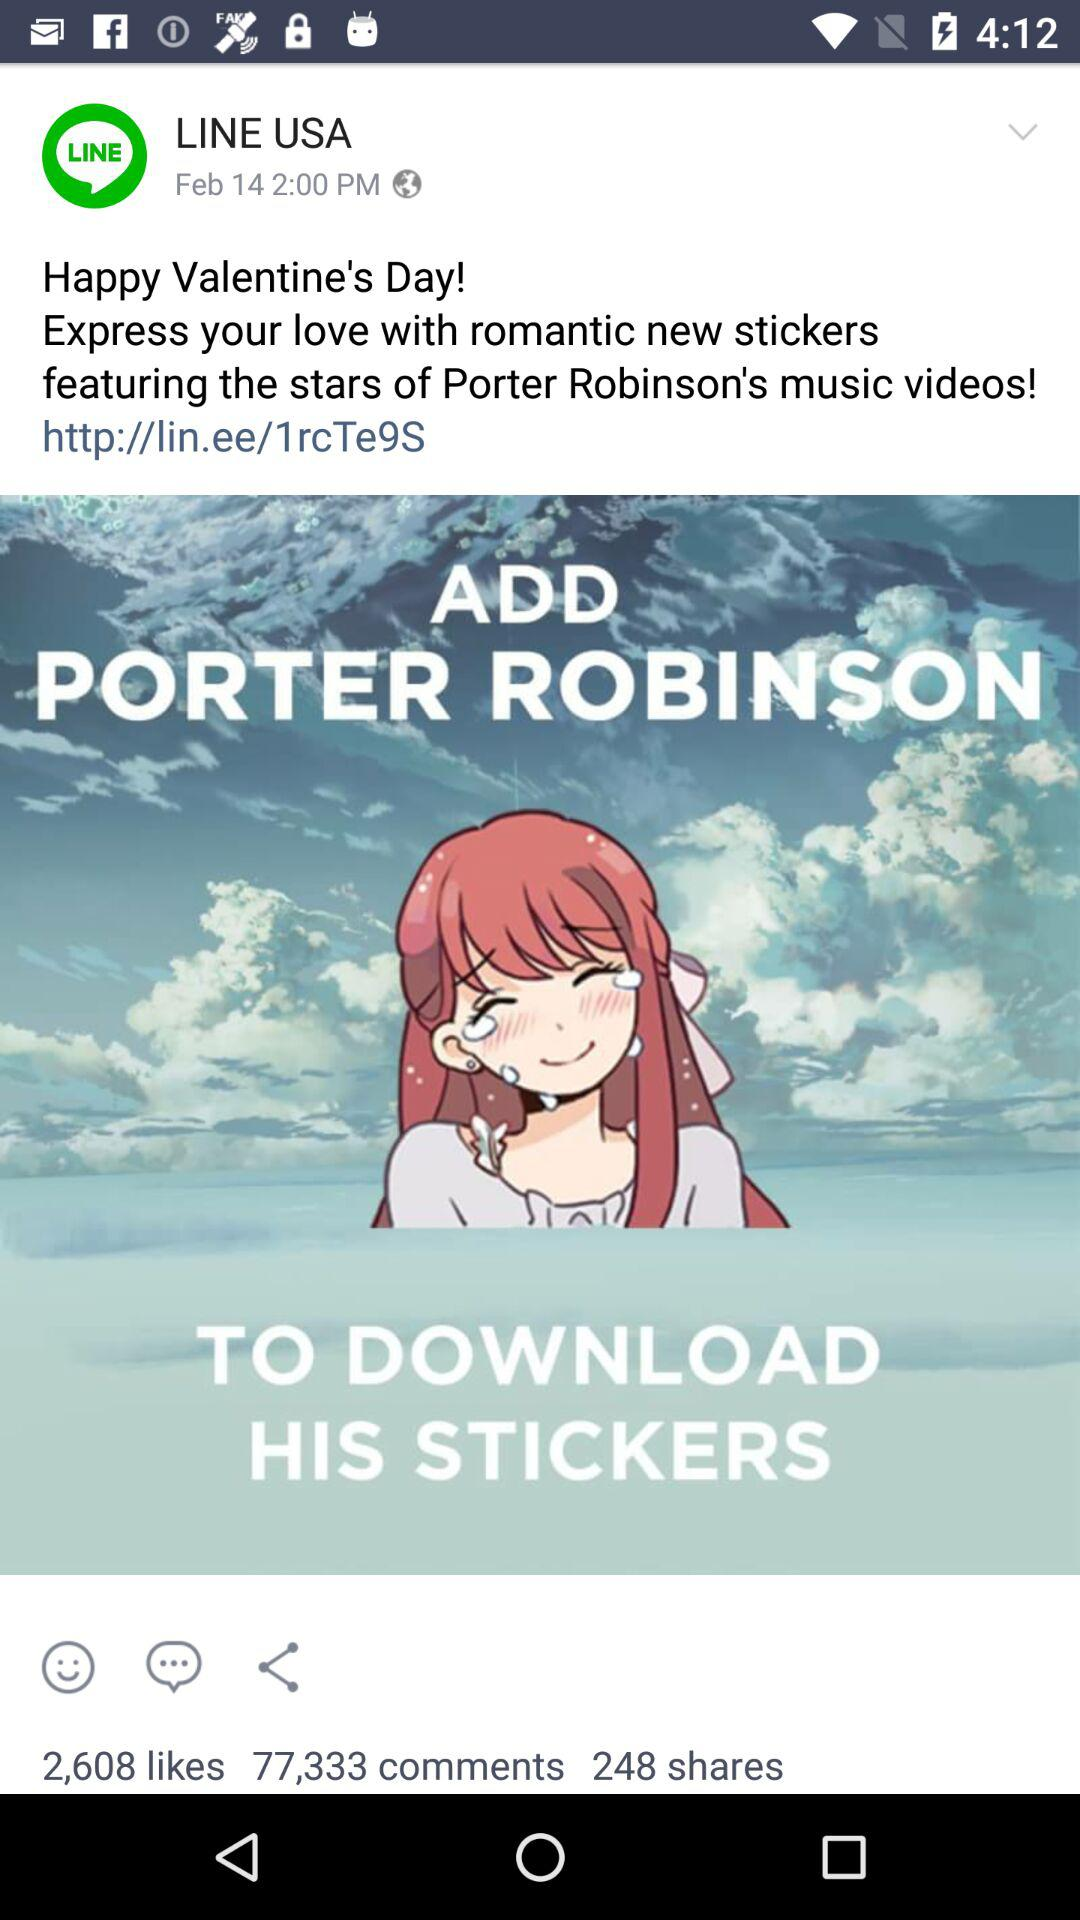How many shares are there?
Answer the question using a single word or phrase. 248 